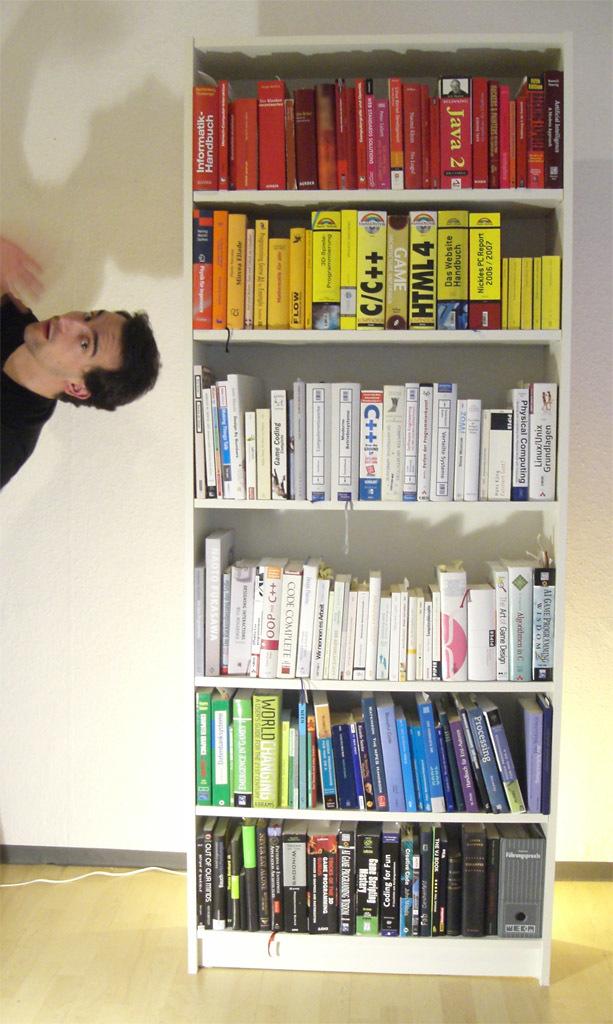What number html is on the book?
Make the answer very short. 4. What number is on the red java book?
Make the answer very short. 2. 